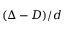<formula> <loc_0><loc_0><loc_500><loc_500>( \Delta - D ) / d</formula> 